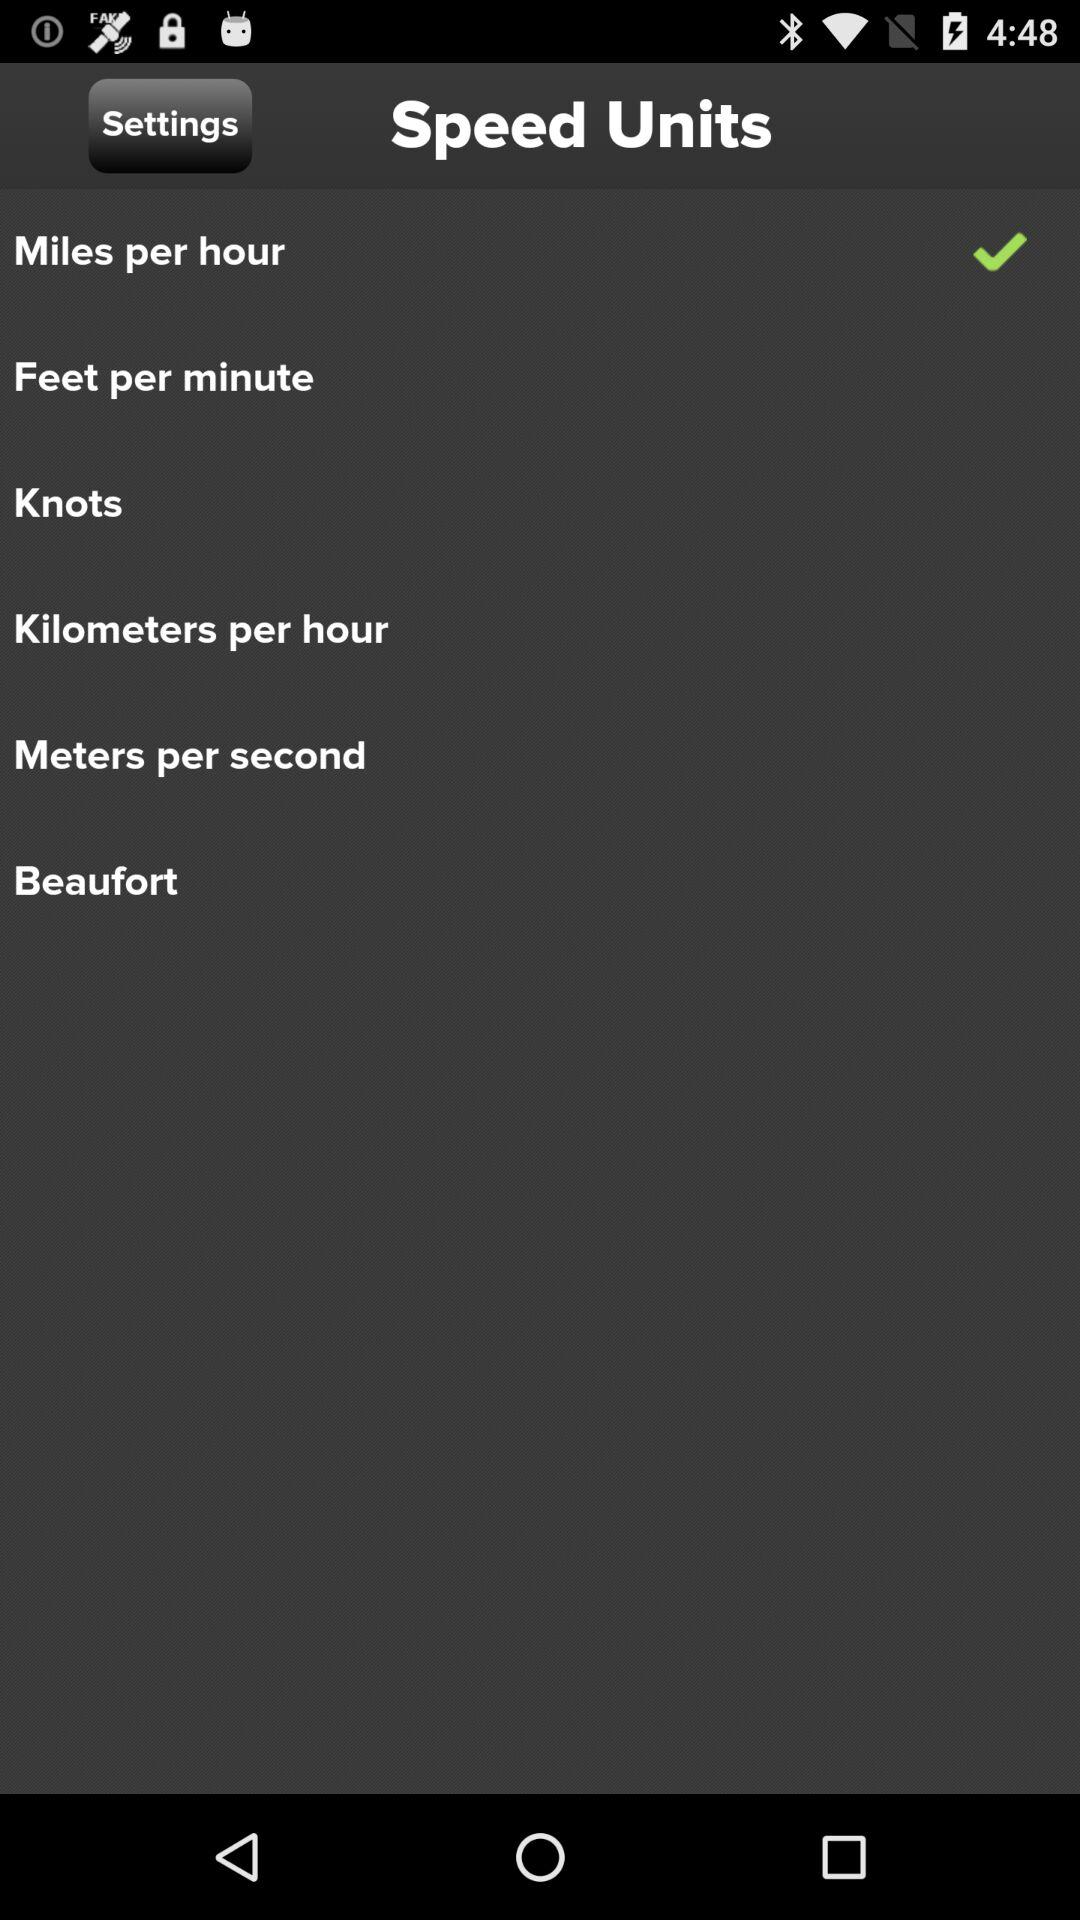How many speed units are there?
Answer the question using a single word or phrase. 6 